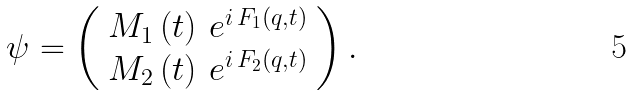<formula> <loc_0><loc_0><loc_500><loc_500>\psi = \left ( \begin{array} { l } { { M _ { 1 } \left ( t \right ) \, e ^ { i \, F _ { 1 } \left ( q , t \right ) } } } \\ { { M _ { 2 } \left ( t \right ) \, e ^ { i \, F _ { 2 } \left ( q , t \right ) } } } \end{array} \right ) . \,</formula> 